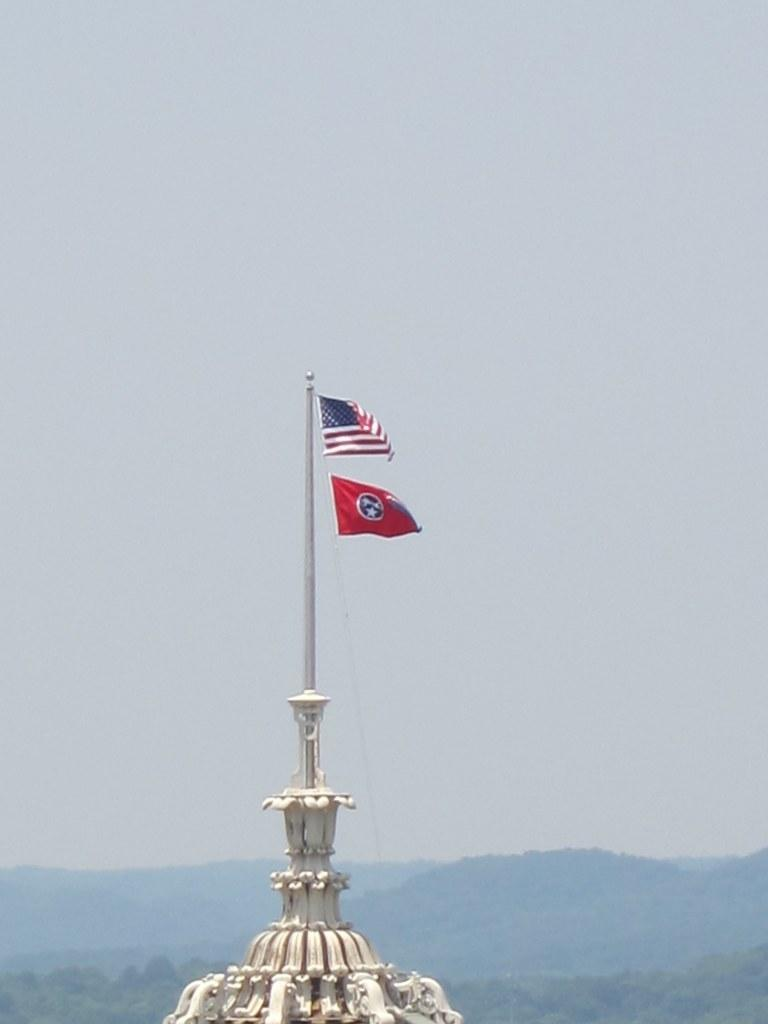What is the main subject of the image? There is a white object in the image. What feature is present on the white object? There is a pole on the white object. What is attached to the pole? There are two flags on the pole. What can be seen in the background of the image? The sky is visible in the background of the image. What type of ink is being used to write on the nail in the image? There is no ink or nail present in the image. How does the behavior of the flags change in the image? The flags do not change their behavior in the image; they are stationary on the pole. 